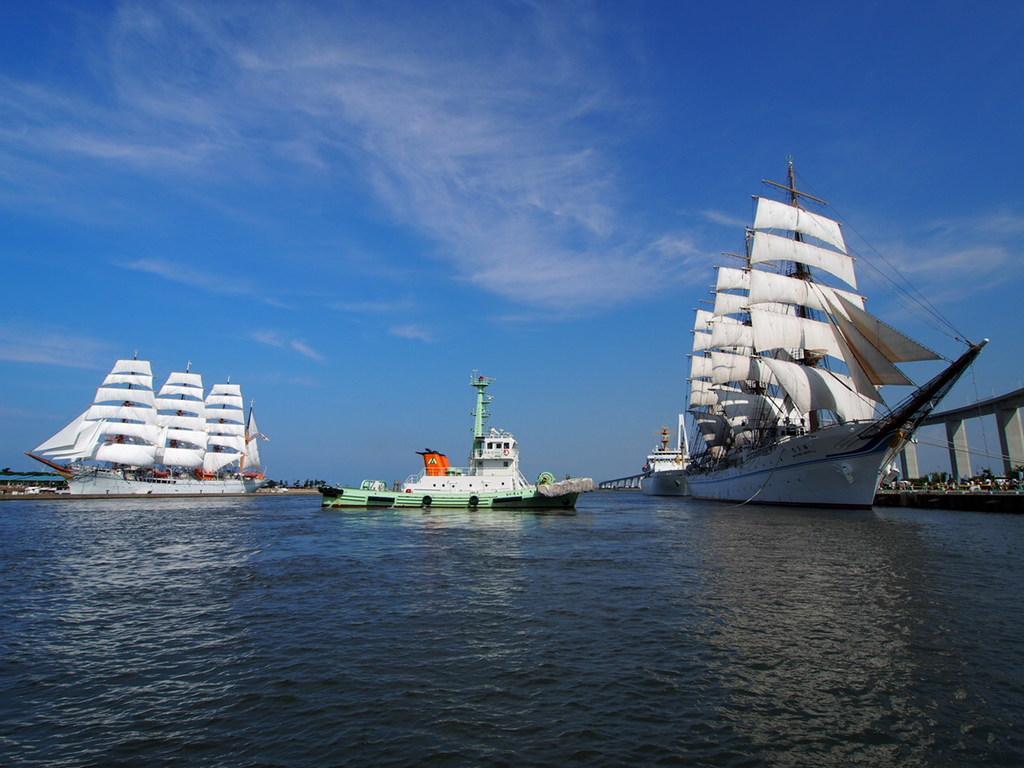In one or two sentences, can you explain what this image depicts? In this picture I can see there are three ships sailing on the water and on to right there is a bridge and the sky is clear. 